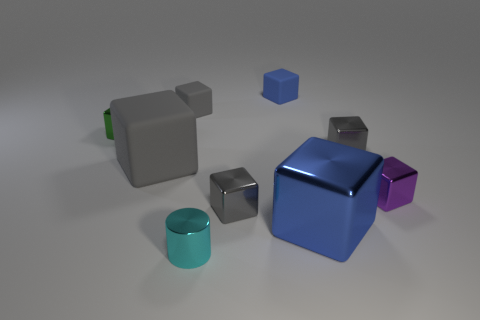There is another cube that is the same color as the big metallic cube; what is its material?
Offer a terse response. Rubber. What number of yellow shiny things are there?
Give a very brief answer. 0. Are there fewer tiny cyan metallic cylinders than big yellow shiny cubes?
Offer a terse response. No. What is the material of the blue thing that is the same size as the green block?
Give a very brief answer. Rubber. How many objects are either big purple metal balls or big blocks?
Your answer should be compact. 2. How many objects are both to the left of the tiny blue object and to the right of the large matte object?
Make the answer very short. 3. Are there fewer large metal objects that are to the right of the purple cube than large green shiny cylinders?
Offer a terse response. No. The blue rubber thing that is the same size as the cyan cylinder is what shape?
Provide a succinct answer. Cube. How many other things are there of the same color as the big metal block?
Ensure brevity in your answer.  1. Is the size of the cyan metallic cylinder the same as the green shiny thing?
Make the answer very short. Yes. 